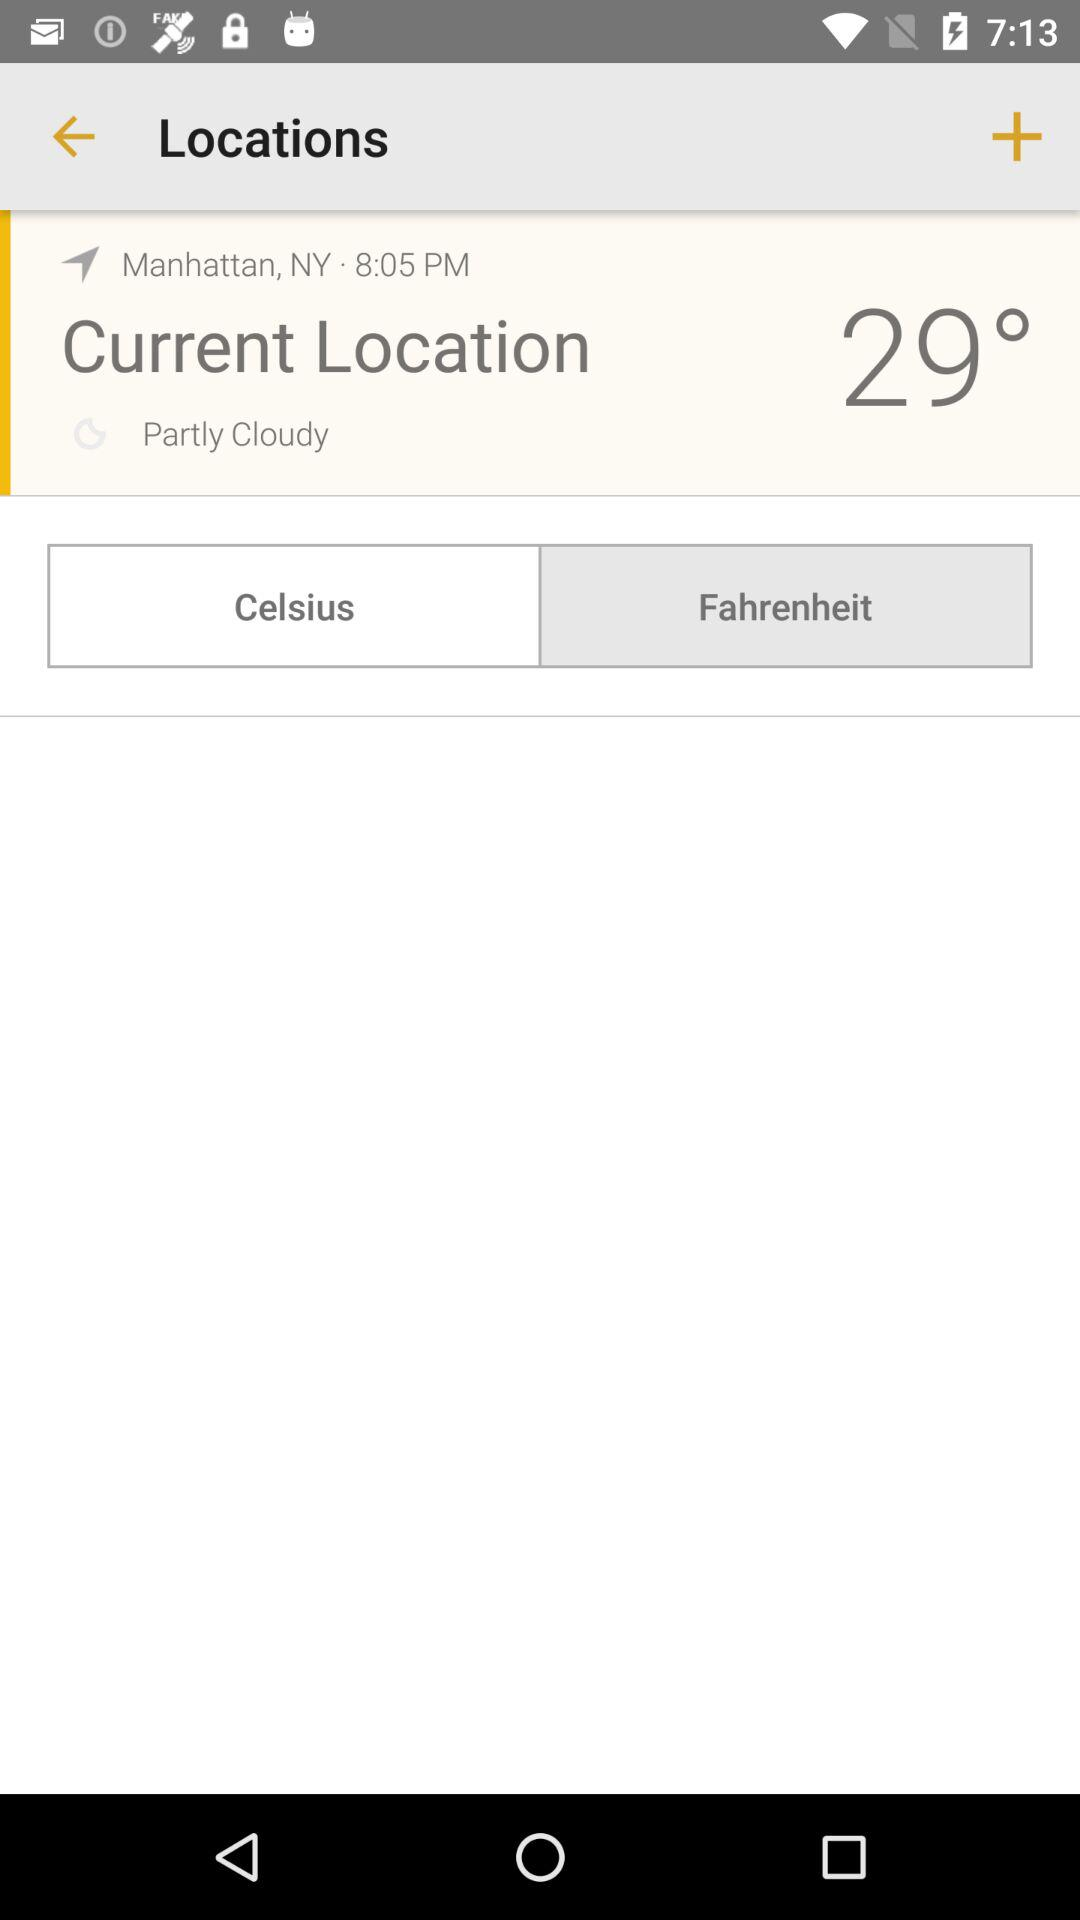What is the location? The location is Manhattan, NY. 